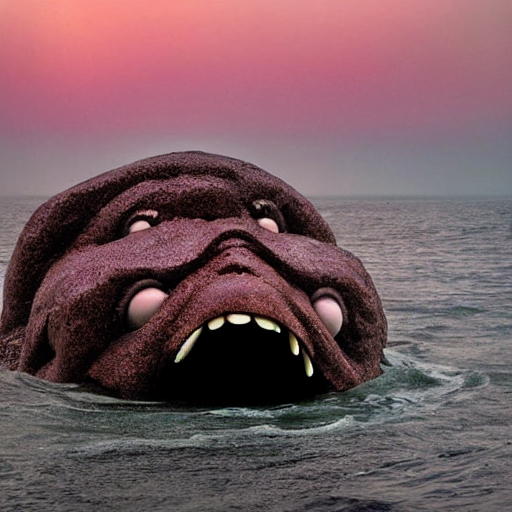What is happening in the image? The image captures a surreal scene where a large, stone-like creature appears to be rising from the ocean. The horizon is lined with a gradient of warm colors, likely indicating the time is around sunrise or sunset. The creature itself has a distinct and fantasy-like design, contributing to a sense of wonder and speculation about the narrative behind this image. What might the creature symbolize? The creature could symbolize various concepts, such as the power of nature, the unknown depths of the ocean, or even human emotions and fears projected onto a mythical being. Its emergence from the sea might represent the surfacing of hidden thoughts or the discovery of something ancient and primordial. 